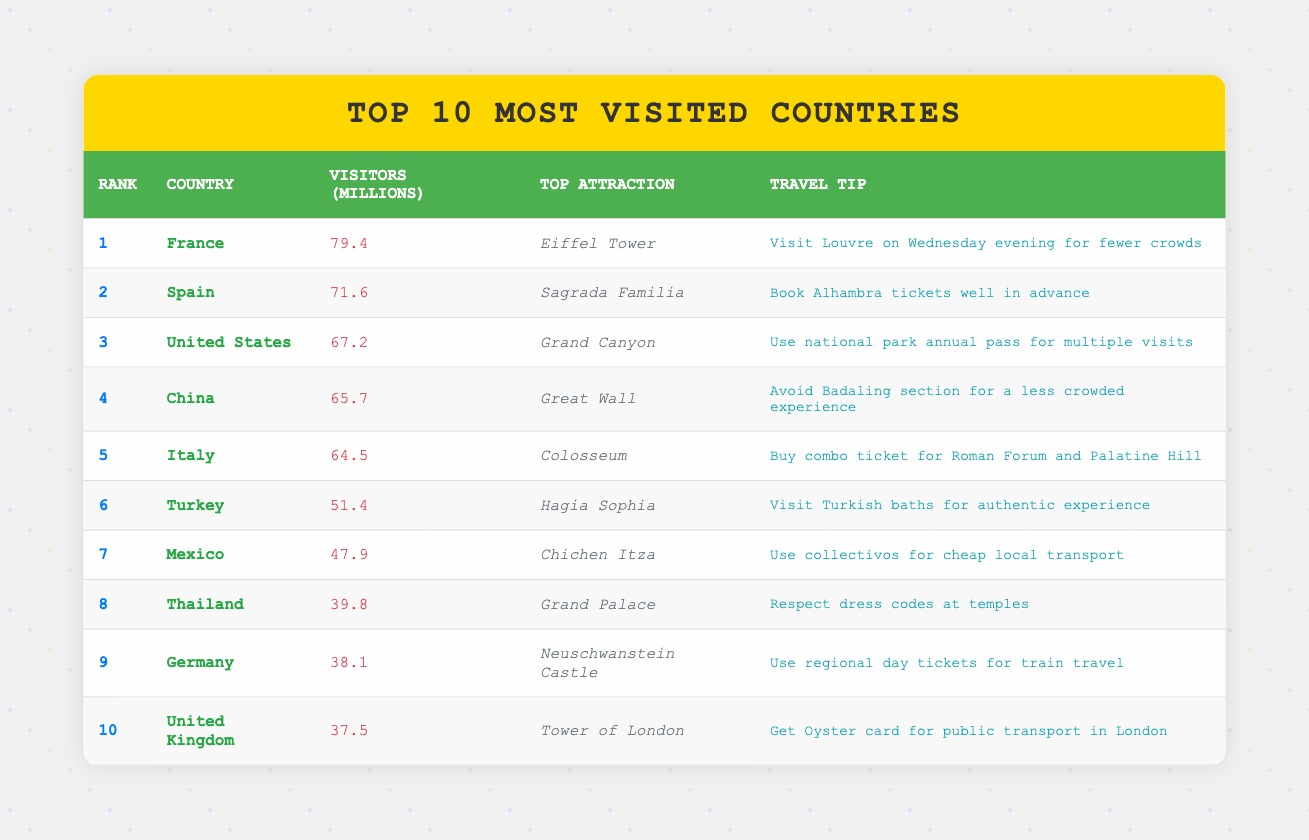What is the top attraction in Italy? The table lists Italy as ranked 5th, with the top attraction being the Colosseum.
Answer: Colosseum How many visitors did China receive in millions? China is ranked 4th in the table, with 65.7 million visitors noted.
Answer: 65.7 Which country had the highest number of visitors? The table shows France at the top with 79.4 million visitors, making it the highest.
Answer: France What is the total number of visitors for the top three countries? The total for the top three is calculated as follows: 79.4 (France) + 71.6 (Spain) + 67.2 (United States) = 218.2 million visitors.
Answer: 218.2 Is the United Kingdom in the top 5 most visited countries? By checking the ranks in the table, the United Kingdom is ranked 10th, thus it is not in the top 5.
Answer: No What travel tip is suggested for visiting the Grand Palace in Thailand? The table indicates that the travel tip for the Grand Palace in Thailand is to respect dress codes at temples.
Answer: Respect dress codes at temples Which country has a travel tip suggesting to book tickets well in advance? The travel tip about booking tickets well in advance refers to Spain, specifically for Alhambra tickets as noted in the table.
Answer: Spain Calculate the average number of visitors for the countries ranked 6 to 10. The number of visitors for ranks 6 to 10 are: 51.4 (Turkey), 47.9 (Mexico), 39.8 (Thailand), 38.1 (Germany), and 37.5 (United Kingdom). Summing these gives: 51.4 + 47.9 + 39.8 + 38.1 + 37.5 = 214.7 million. The average is therefore 214.7 million divided by 5, which equals 42.94 million visitors.
Answer: 42.94 What is the travel tip for visitors going to the Tower of London? The travel tip for the Tower of London is to get an Oyster card for public transport in London, as stated in the table.
Answer: Get Oyster card for public transport in London 